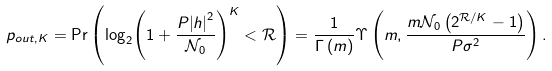<formula> <loc_0><loc_0><loc_500><loc_500>{ p _ { o u t , K } } = \Pr \left ( { { { \log } _ { 2 } } { { \left ( { 1 + \frac { { P } { { \left | { h } \right | } ^ { 2 } } } { \mathcal { N } _ { 0 } } } \right ) } ^ { K } } < \mathcal { R } } \right ) = \frac { 1 } { \Gamma \left ( m \right ) } \Upsilon \left ( { m , \frac { { m \mathcal { N } _ { 0 } \left ( { { 2 ^ { \mathcal { R } / K } } - 1 } \right ) } } { { { P } { \sigma } ^ { 2 } } } } \right ) .</formula> 